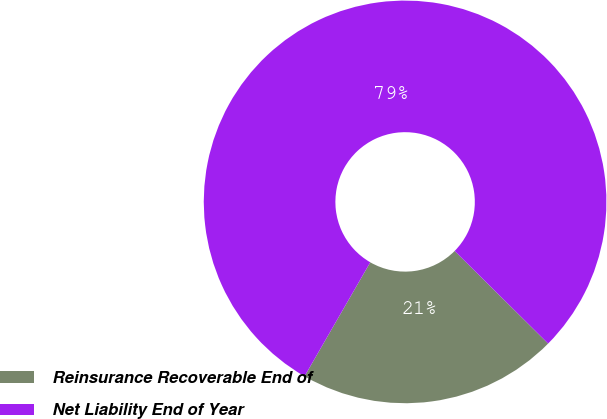Convert chart. <chart><loc_0><loc_0><loc_500><loc_500><pie_chart><fcel>Reinsurance Recoverable End of<fcel>Net Liability End of Year<nl><fcel>20.9%<fcel>79.1%<nl></chart> 